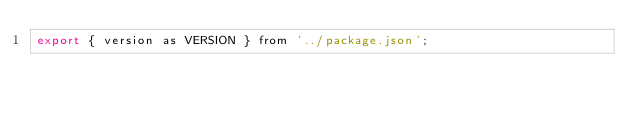<code> <loc_0><loc_0><loc_500><loc_500><_JavaScript_>export { version as VERSION } from '../package.json';</code> 